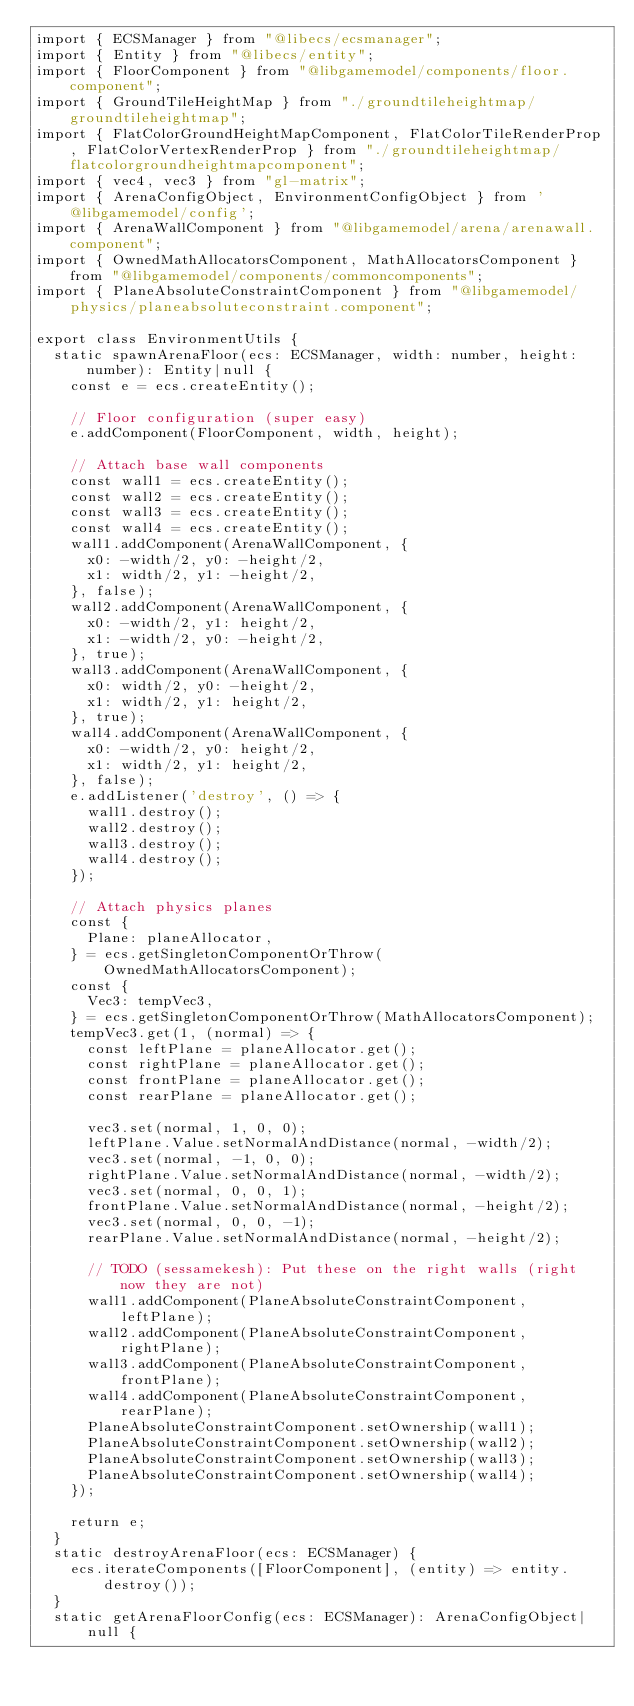Convert code to text. <code><loc_0><loc_0><loc_500><loc_500><_TypeScript_>import { ECSManager } from "@libecs/ecsmanager";
import { Entity } from "@libecs/entity";
import { FloorComponent } from "@libgamemodel/components/floor.component";
import { GroundTileHeightMap } from "./groundtileheightmap/groundtileheightmap";
import { FlatColorGroundHeightMapComponent, FlatColorTileRenderProp, FlatColorVertexRenderProp } from "./groundtileheightmap/flatcolorgroundheightmapcomponent";
import { vec4, vec3 } from "gl-matrix";
import { ArenaConfigObject, EnvironmentConfigObject } from '@libgamemodel/config';
import { ArenaWallComponent } from "@libgamemodel/arena/arenawall.component";
import { OwnedMathAllocatorsComponent, MathAllocatorsComponent } from "@libgamemodel/components/commoncomponents";
import { PlaneAbsoluteConstraintComponent } from "@libgamemodel/physics/planeabsoluteconstraint.component";

export class EnvironmentUtils {
  static spawnArenaFloor(ecs: ECSManager, width: number, height: number): Entity|null {
    const e = ecs.createEntity();

    // Floor configuration (super easy)
    e.addComponent(FloorComponent, width, height);

    // Attach base wall components
    const wall1 = ecs.createEntity();
    const wall2 = ecs.createEntity();
    const wall3 = ecs.createEntity();
    const wall4 = ecs.createEntity();
    wall1.addComponent(ArenaWallComponent, {
      x0: -width/2, y0: -height/2,
      x1: width/2, y1: -height/2,
    }, false);
    wall2.addComponent(ArenaWallComponent, {
      x0: -width/2, y1: height/2,
      x1: -width/2, y0: -height/2,
    }, true);
    wall3.addComponent(ArenaWallComponent, {
      x0: width/2, y0: -height/2,
      x1: width/2, y1: height/2,
    }, true);
    wall4.addComponent(ArenaWallComponent, {
      x0: -width/2, y0: height/2,
      x1: width/2, y1: height/2,
    }, false);
    e.addListener('destroy', () => {
      wall1.destroy();
      wall2.destroy();
      wall3.destroy();
      wall4.destroy();
    });

    // Attach physics planes
    const {
      Plane: planeAllocator,
    } = ecs.getSingletonComponentOrThrow(OwnedMathAllocatorsComponent);
    const {
      Vec3: tempVec3,
    } = ecs.getSingletonComponentOrThrow(MathAllocatorsComponent);
    tempVec3.get(1, (normal) => {
      const leftPlane = planeAllocator.get();
      const rightPlane = planeAllocator.get();
      const frontPlane = planeAllocator.get();
      const rearPlane = planeAllocator.get();

      vec3.set(normal, 1, 0, 0);
      leftPlane.Value.setNormalAndDistance(normal, -width/2);
      vec3.set(normal, -1, 0, 0);
      rightPlane.Value.setNormalAndDistance(normal, -width/2);
      vec3.set(normal, 0, 0, 1);
      frontPlane.Value.setNormalAndDistance(normal, -height/2);
      vec3.set(normal, 0, 0, -1);
      rearPlane.Value.setNormalAndDistance(normal, -height/2);

      // TODO (sessamekesh): Put these on the right walls (right now they are not)
      wall1.addComponent(PlaneAbsoluteConstraintComponent, leftPlane);
      wall2.addComponent(PlaneAbsoluteConstraintComponent, rightPlane);
      wall3.addComponent(PlaneAbsoluteConstraintComponent, frontPlane);
      wall4.addComponent(PlaneAbsoluteConstraintComponent, rearPlane);
      PlaneAbsoluteConstraintComponent.setOwnership(wall1);
      PlaneAbsoluteConstraintComponent.setOwnership(wall2);
      PlaneAbsoluteConstraintComponent.setOwnership(wall3);
      PlaneAbsoluteConstraintComponent.setOwnership(wall4);
    });

    return e;
  }
  static destroyArenaFloor(ecs: ECSManager) {
    ecs.iterateComponents([FloorComponent], (entity) => entity.destroy());
  }
  static getArenaFloorConfig(ecs: ECSManager): ArenaConfigObject|null {</code> 